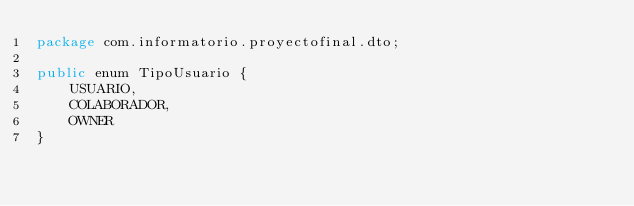<code> <loc_0><loc_0><loc_500><loc_500><_Java_>package com.informatorio.proyectofinal.dto;

public enum TipoUsuario {
    USUARIO,
    COLABORADOR,
    OWNER
}
</code> 